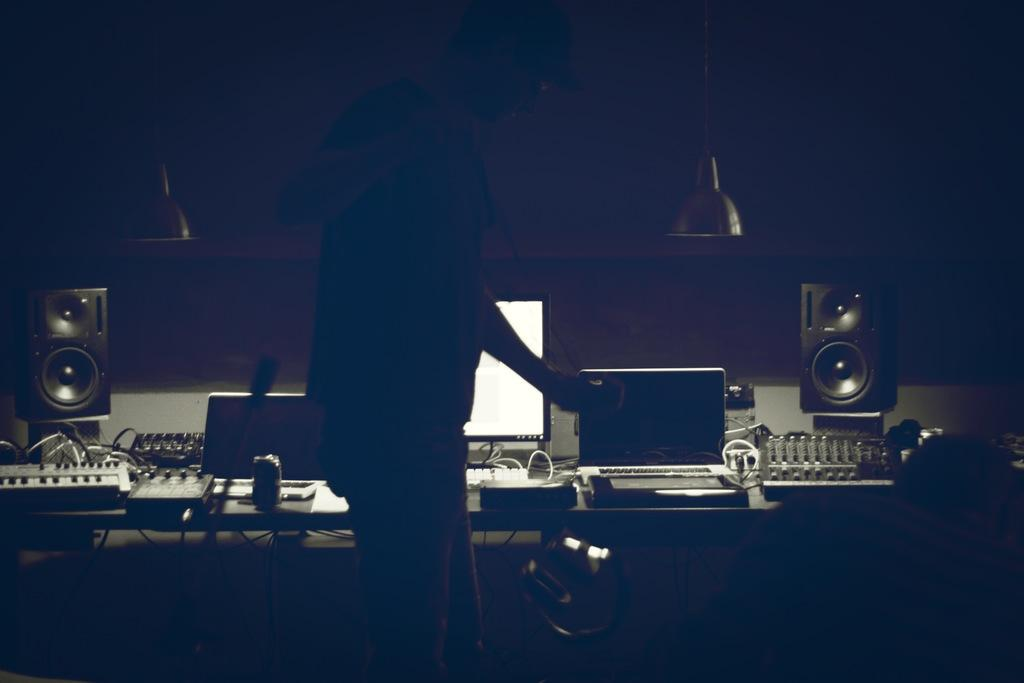Who or what is present in the image? There is a person in the image. What can be seen in the background or surrounding the person? There are lights in the image. What is the main object in the image? There is a table in the image. What electronic devices are on the table? There are laptops, a keyboard, and a sound box on the table. What else is on the table? There is a tin on the table. How does the person's stomach feel in the image? There is no information about the person's stomach in the image, so it cannot be determined how they feel. 